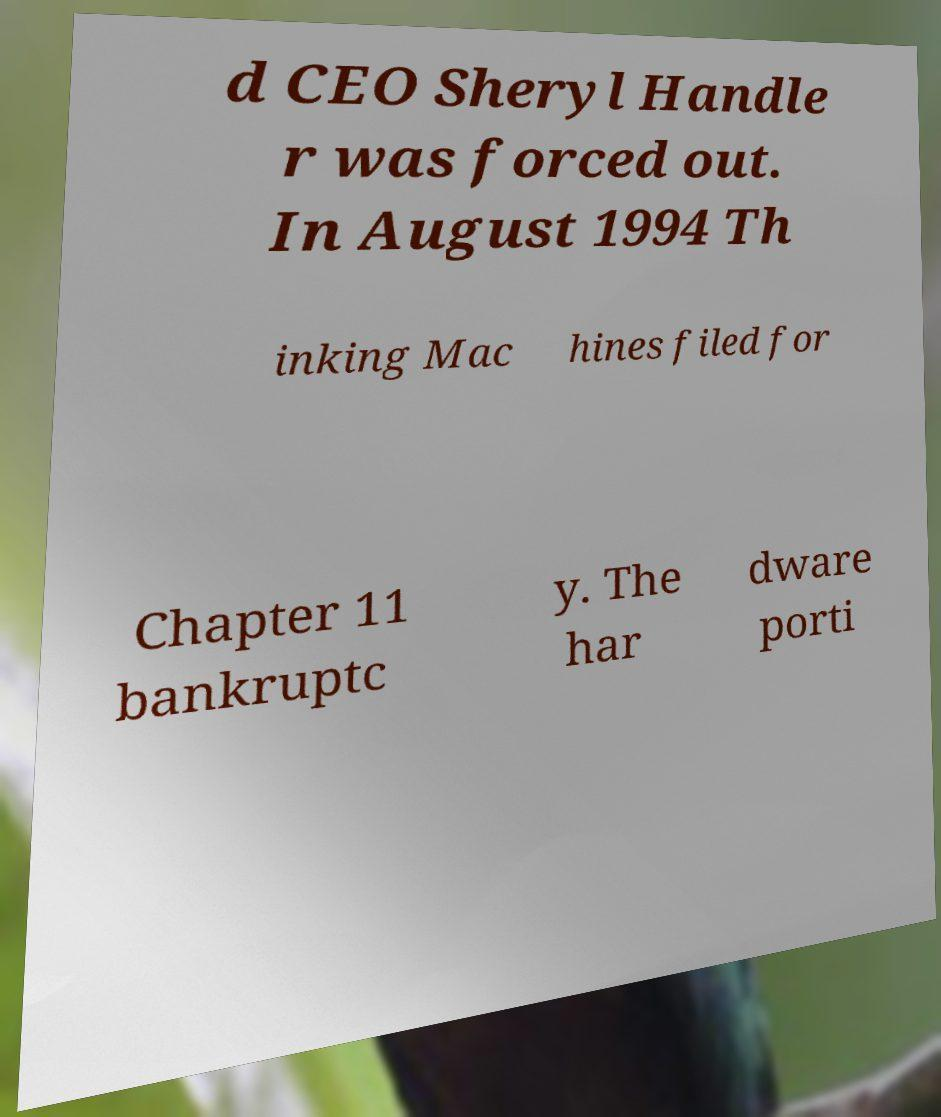There's text embedded in this image that I need extracted. Can you transcribe it verbatim? d CEO Sheryl Handle r was forced out. In August 1994 Th inking Mac hines filed for Chapter 11 bankruptc y. The har dware porti 